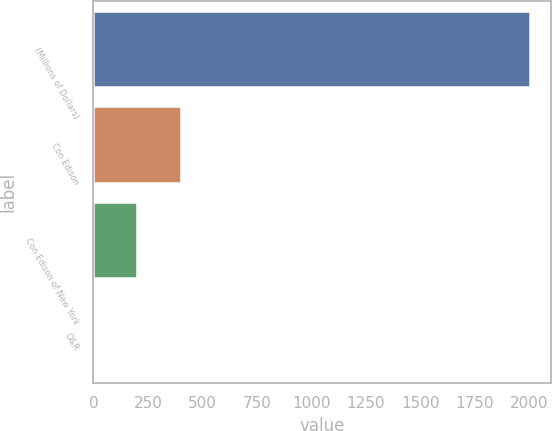<chart> <loc_0><loc_0><loc_500><loc_500><bar_chart><fcel>(Millions of Dollars)<fcel>Con Edison<fcel>Con Edison of New York<fcel>O&R<nl><fcel>2003<fcel>401.4<fcel>201.2<fcel>1<nl></chart> 